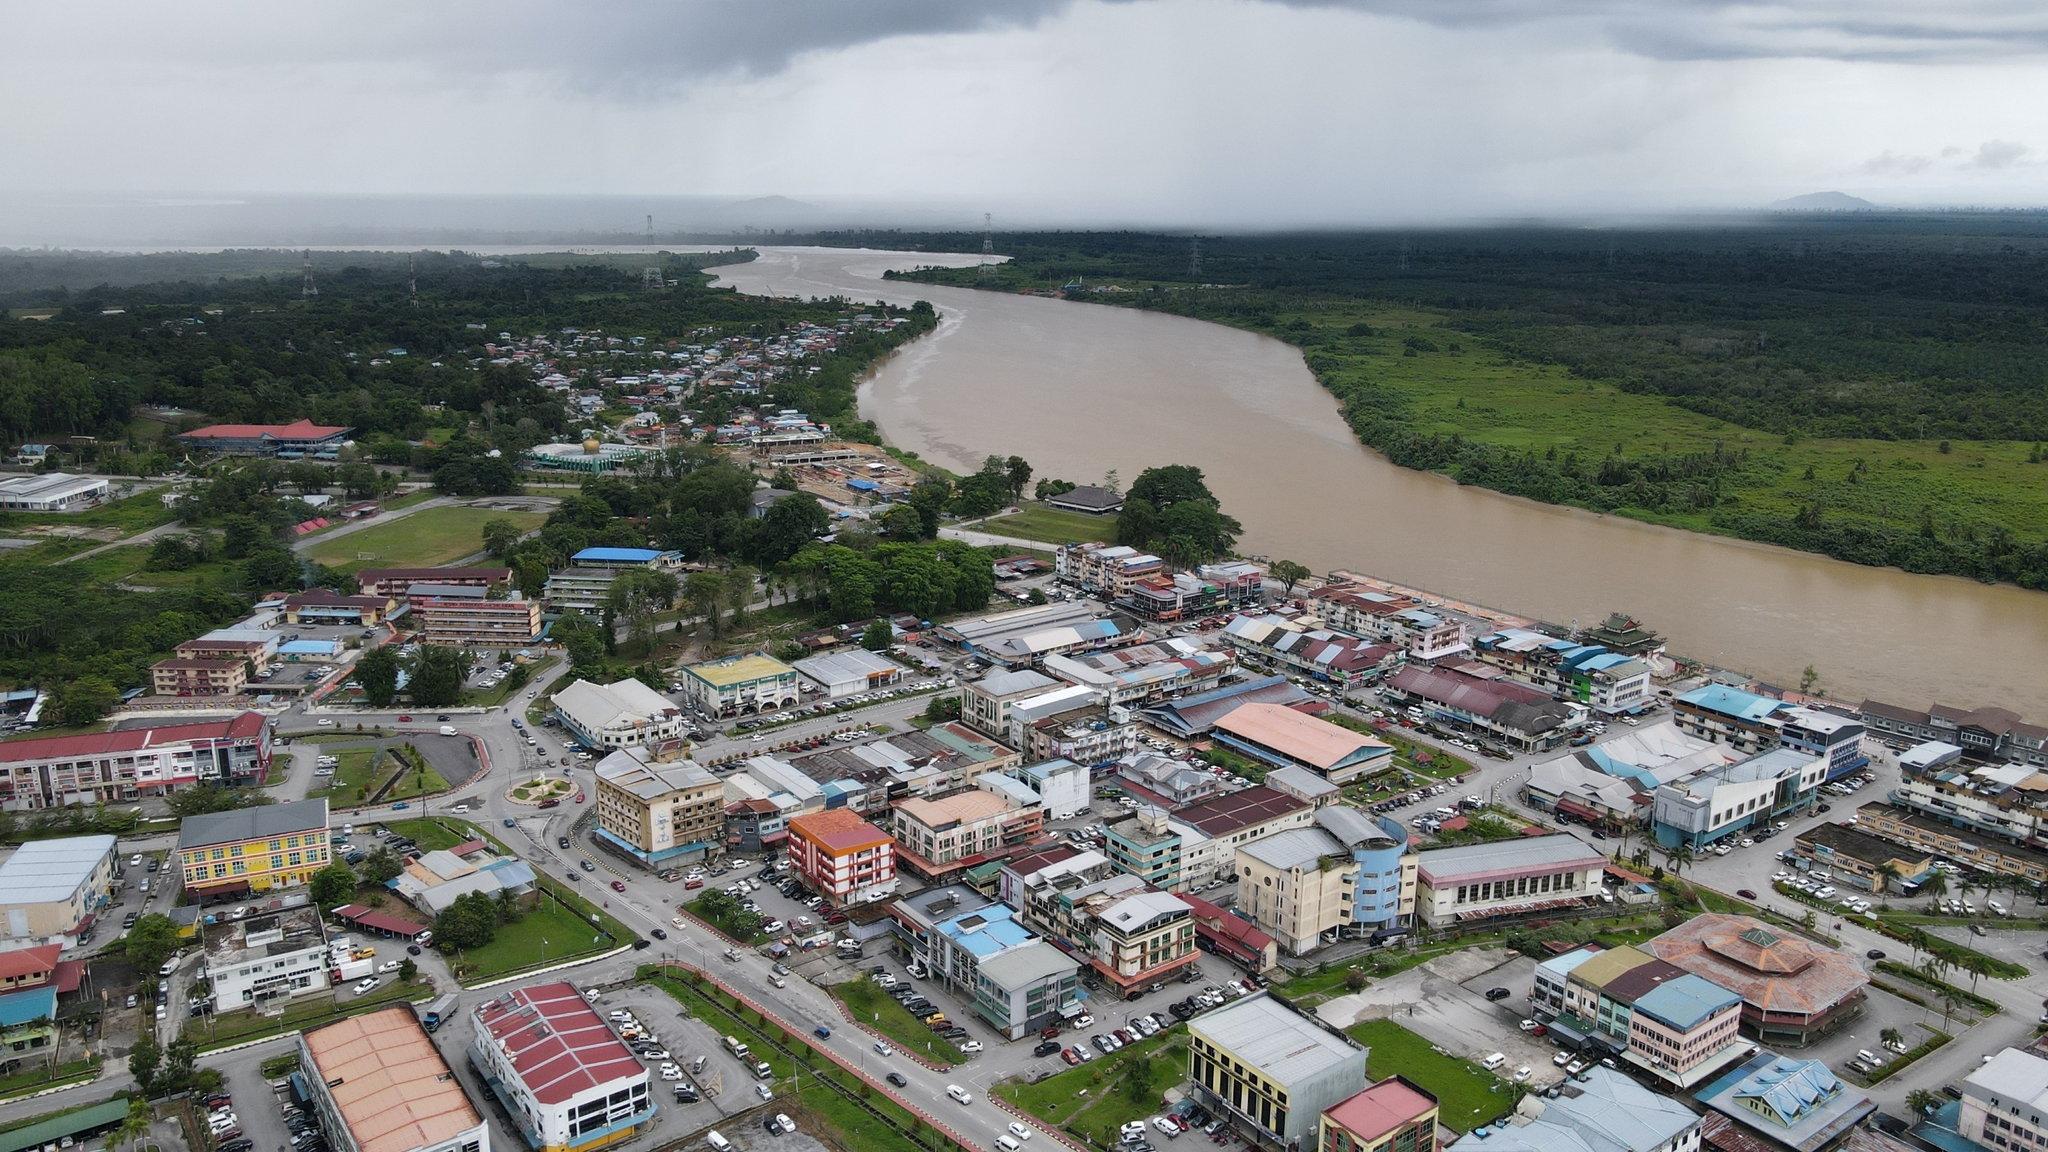What is this photo about'? This image captures an aerial view of a lively town situated along the banks of a wide, brown river. The town is densely packed with variously colored and sized buildings, contributing to a vibrant mosaic of urban life. The river is a prominent natural feature, and it adds a significant scenic element to the landscape. The sky is overcast, filled with clouds that suggest a typical rainy day. One can see the horizon in the distance, which gives a sense of depth and scale to the scene. The high-angle perspective offers a comprehensive view of the town and its surroundings, providing detailed insights into the urban layout and its relationship with the natural environment. 